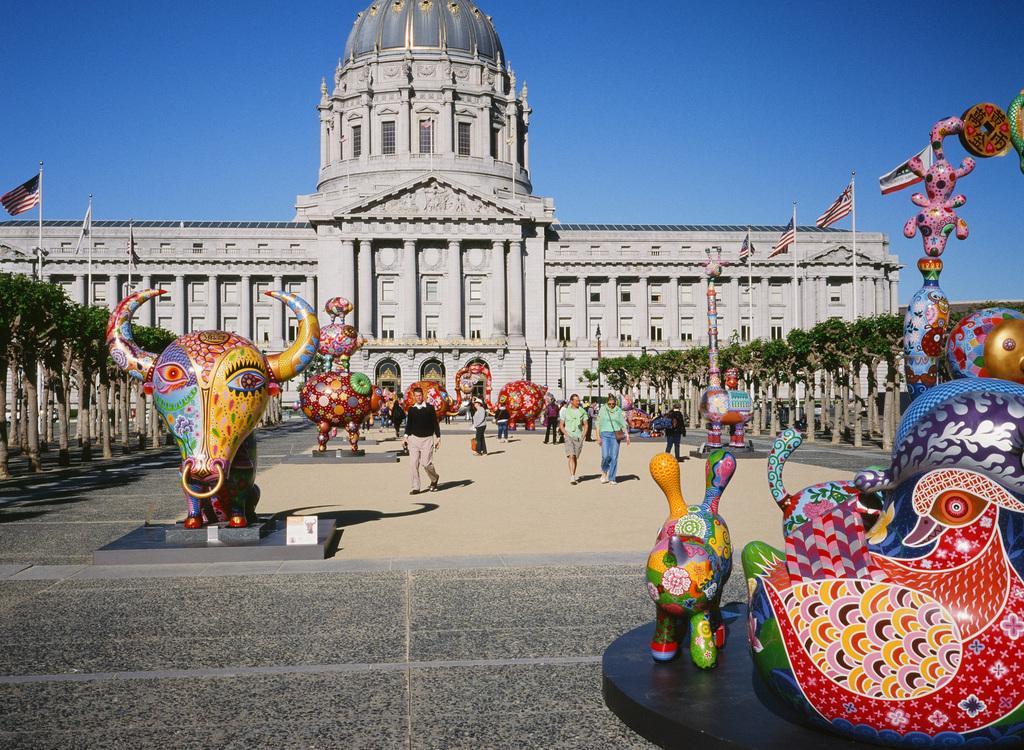Describe this image in one or two sentences. In the center of the image we can see a few statues and a few people with different costumes. In the background, we can see the sky, trees, flags and one building. 